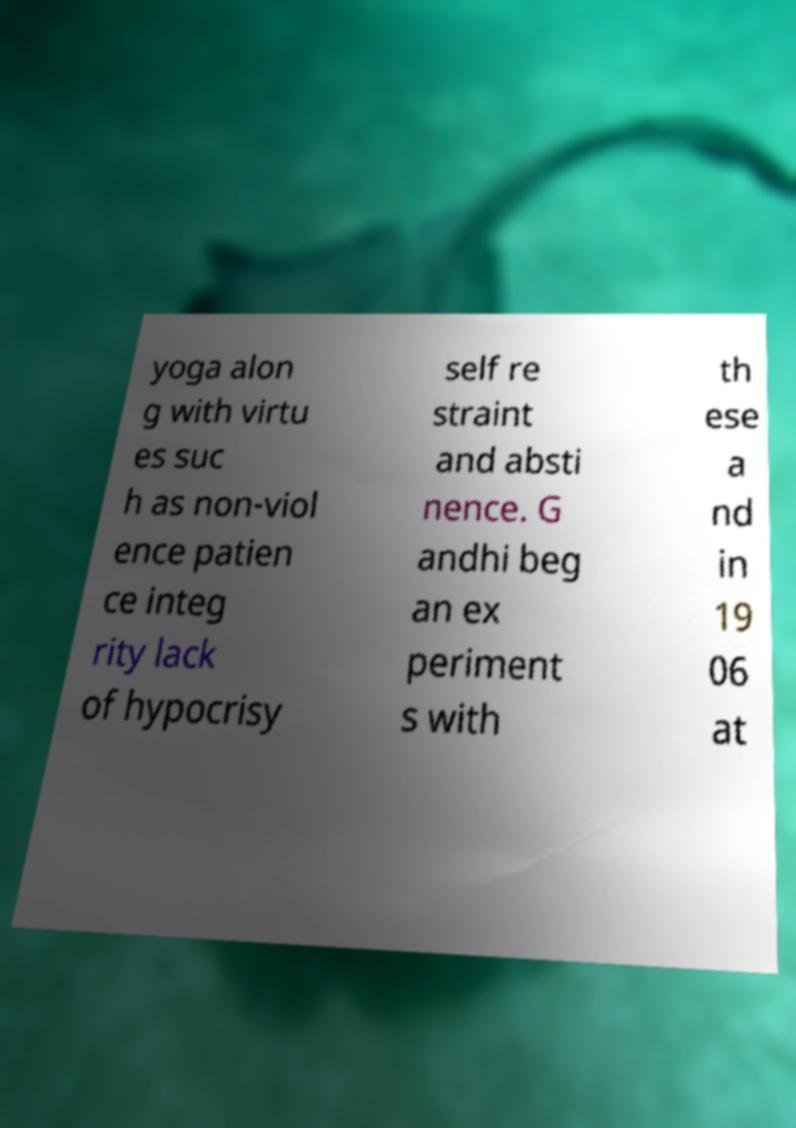Can you read and provide the text displayed in the image?This photo seems to have some interesting text. Can you extract and type it out for me? yoga alon g with virtu es suc h as non-viol ence patien ce integ rity lack of hypocrisy self re straint and absti nence. G andhi beg an ex periment s with th ese a nd in 19 06 at 